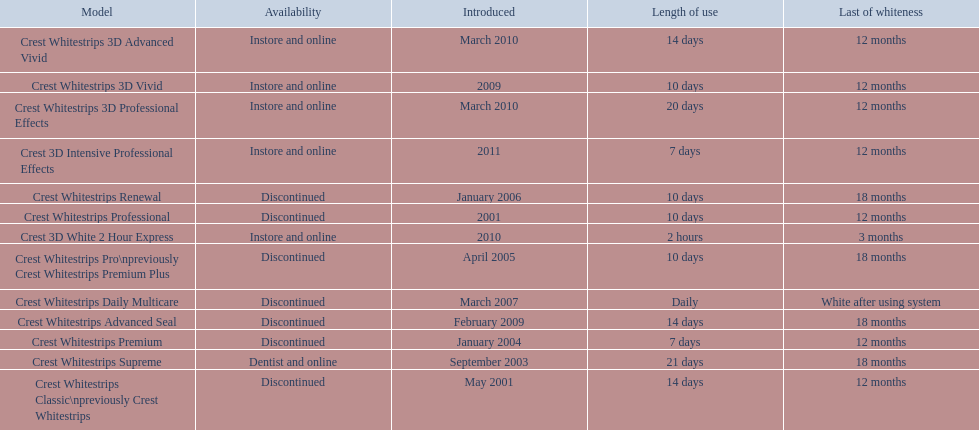Which of these products are discontinued? Crest Whitestrips Classic\npreviously Crest Whitestrips, Crest Whitestrips Professional, Crest Whitestrips Premium, Crest Whitestrips Pro\npreviously Crest Whitestrips Premium Plus, Crest Whitestrips Renewal, Crest Whitestrips Daily Multicare, Crest Whitestrips Advanced Seal. Which of these products have a 14 day length of use? Crest Whitestrips Classic\npreviously Crest Whitestrips, Crest Whitestrips Advanced Seal. Which of these products was introduced in 2009? Crest Whitestrips Advanced Seal. 